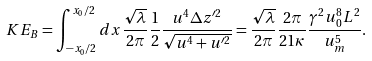<formula> <loc_0><loc_0><loc_500><loc_500>K E _ { B } = \int _ { - x _ { 0 } / 2 } ^ { x _ { 0 } / 2 } d x \frac { \sqrt { \lambda } } { 2 \pi } \frac { 1 } { 2 } \frac { u ^ { 4 } \Delta z ^ { \prime 2 } } { \sqrt { u ^ { 4 } + u ^ { \prime 2 } } } = \frac { \sqrt { \lambda } } { 2 \pi } \frac { 2 \pi } { 2 1 \kappa } \frac { \gamma ^ { 2 } u _ { 0 } ^ { 8 } L ^ { 2 } } { u _ { m } ^ { 5 } } .</formula> 